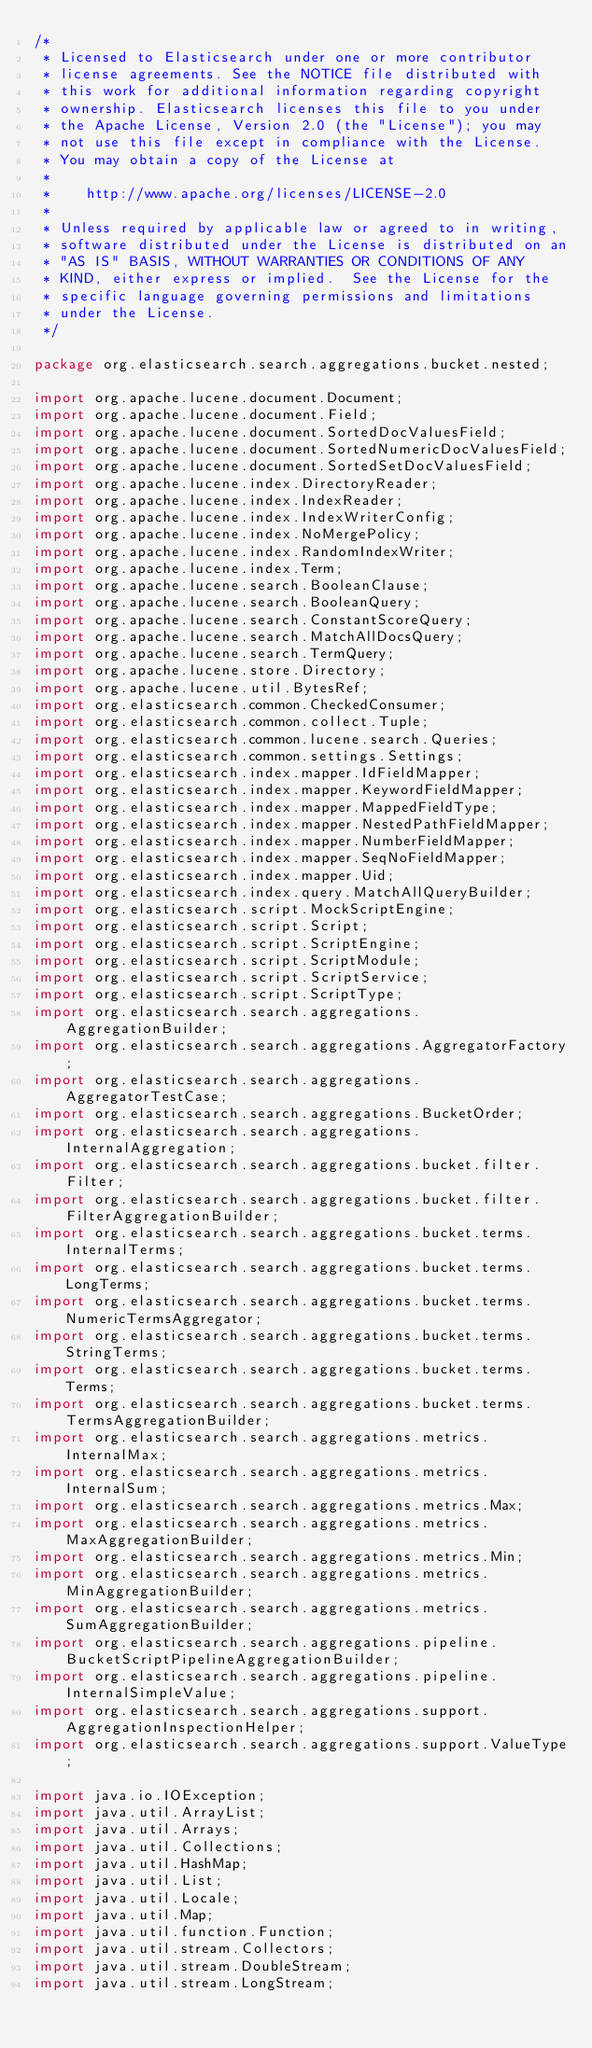<code> <loc_0><loc_0><loc_500><loc_500><_Java_>/*
 * Licensed to Elasticsearch under one or more contributor
 * license agreements. See the NOTICE file distributed with
 * this work for additional information regarding copyright
 * ownership. Elasticsearch licenses this file to you under
 * the Apache License, Version 2.0 (the "License"); you may
 * not use this file except in compliance with the License.
 * You may obtain a copy of the License at
 *
 *    http://www.apache.org/licenses/LICENSE-2.0
 *
 * Unless required by applicable law or agreed to in writing,
 * software distributed under the License is distributed on an
 * "AS IS" BASIS, WITHOUT WARRANTIES OR CONDITIONS OF ANY
 * KIND, either express or implied.  See the License for the
 * specific language governing permissions and limitations
 * under the License.
 */

package org.elasticsearch.search.aggregations.bucket.nested;

import org.apache.lucene.document.Document;
import org.apache.lucene.document.Field;
import org.apache.lucene.document.SortedDocValuesField;
import org.apache.lucene.document.SortedNumericDocValuesField;
import org.apache.lucene.document.SortedSetDocValuesField;
import org.apache.lucene.index.DirectoryReader;
import org.apache.lucene.index.IndexReader;
import org.apache.lucene.index.IndexWriterConfig;
import org.apache.lucene.index.NoMergePolicy;
import org.apache.lucene.index.RandomIndexWriter;
import org.apache.lucene.index.Term;
import org.apache.lucene.search.BooleanClause;
import org.apache.lucene.search.BooleanQuery;
import org.apache.lucene.search.ConstantScoreQuery;
import org.apache.lucene.search.MatchAllDocsQuery;
import org.apache.lucene.search.TermQuery;
import org.apache.lucene.store.Directory;
import org.apache.lucene.util.BytesRef;
import org.elasticsearch.common.CheckedConsumer;
import org.elasticsearch.common.collect.Tuple;
import org.elasticsearch.common.lucene.search.Queries;
import org.elasticsearch.common.settings.Settings;
import org.elasticsearch.index.mapper.IdFieldMapper;
import org.elasticsearch.index.mapper.KeywordFieldMapper;
import org.elasticsearch.index.mapper.MappedFieldType;
import org.elasticsearch.index.mapper.NestedPathFieldMapper;
import org.elasticsearch.index.mapper.NumberFieldMapper;
import org.elasticsearch.index.mapper.SeqNoFieldMapper;
import org.elasticsearch.index.mapper.Uid;
import org.elasticsearch.index.query.MatchAllQueryBuilder;
import org.elasticsearch.script.MockScriptEngine;
import org.elasticsearch.script.Script;
import org.elasticsearch.script.ScriptEngine;
import org.elasticsearch.script.ScriptModule;
import org.elasticsearch.script.ScriptService;
import org.elasticsearch.script.ScriptType;
import org.elasticsearch.search.aggregations.AggregationBuilder;
import org.elasticsearch.search.aggregations.AggregatorFactory;
import org.elasticsearch.search.aggregations.AggregatorTestCase;
import org.elasticsearch.search.aggregations.BucketOrder;
import org.elasticsearch.search.aggregations.InternalAggregation;
import org.elasticsearch.search.aggregations.bucket.filter.Filter;
import org.elasticsearch.search.aggregations.bucket.filter.FilterAggregationBuilder;
import org.elasticsearch.search.aggregations.bucket.terms.InternalTerms;
import org.elasticsearch.search.aggregations.bucket.terms.LongTerms;
import org.elasticsearch.search.aggregations.bucket.terms.NumericTermsAggregator;
import org.elasticsearch.search.aggregations.bucket.terms.StringTerms;
import org.elasticsearch.search.aggregations.bucket.terms.Terms;
import org.elasticsearch.search.aggregations.bucket.terms.TermsAggregationBuilder;
import org.elasticsearch.search.aggregations.metrics.InternalMax;
import org.elasticsearch.search.aggregations.metrics.InternalSum;
import org.elasticsearch.search.aggregations.metrics.Max;
import org.elasticsearch.search.aggregations.metrics.MaxAggregationBuilder;
import org.elasticsearch.search.aggregations.metrics.Min;
import org.elasticsearch.search.aggregations.metrics.MinAggregationBuilder;
import org.elasticsearch.search.aggregations.metrics.SumAggregationBuilder;
import org.elasticsearch.search.aggregations.pipeline.BucketScriptPipelineAggregationBuilder;
import org.elasticsearch.search.aggregations.pipeline.InternalSimpleValue;
import org.elasticsearch.search.aggregations.support.AggregationInspectionHelper;
import org.elasticsearch.search.aggregations.support.ValueType;

import java.io.IOException;
import java.util.ArrayList;
import java.util.Arrays;
import java.util.Collections;
import java.util.HashMap;
import java.util.List;
import java.util.Locale;
import java.util.Map;
import java.util.function.Function;
import java.util.stream.Collectors;
import java.util.stream.DoubleStream;
import java.util.stream.LongStream;
</code> 